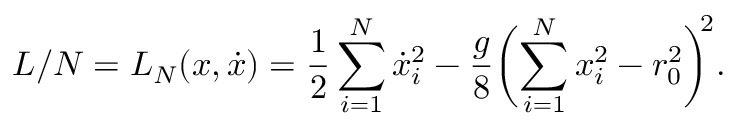<formula> <loc_0><loc_0><loc_500><loc_500>L / N = L _ { N } ( x , \dot { x } ) = \frac { 1 } { 2 } \sum _ { i = 1 } ^ { N } \dot { x } _ { i } ^ { 2 } - \frac { g } { 8 } \left ( \sum _ { i = 1 } ^ { N } x _ { i } ^ { 2 } - r _ { 0 } ^ { 2 } \right ) ^ { \, 2 } .</formula> 